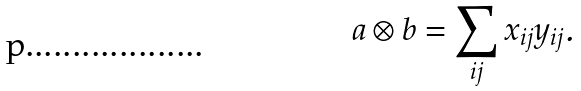<formula> <loc_0><loc_0><loc_500><loc_500>a \otimes b = \sum _ { i j } x _ { i j } y _ { i j } .</formula> 